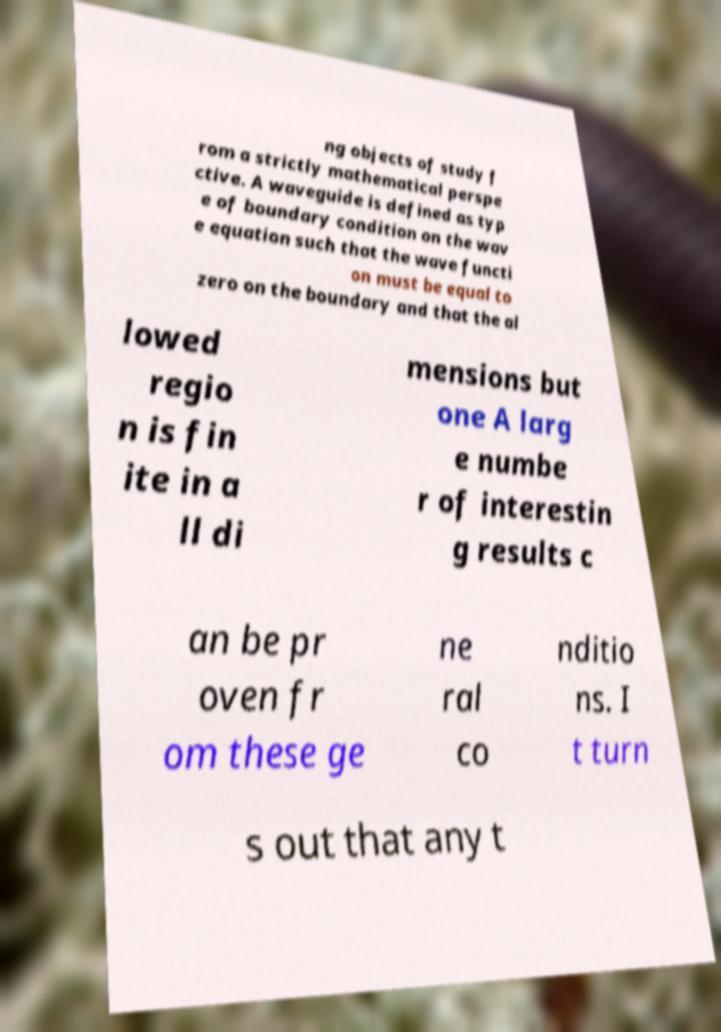I need the written content from this picture converted into text. Can you do that? ng objects of study f rom a strictly mathematical perspe ctive. A waveguide is defined as typ e of boundary condition on the wav e equation such that the wave functi on must be equal to zero on the boundary and that the al lowed regio n is fin ite in a ll di mensions but one A larg e numbe r of interestin g results c an be pr oven fr om these ge ne ral co nditio ns. I t turn s out that any t 